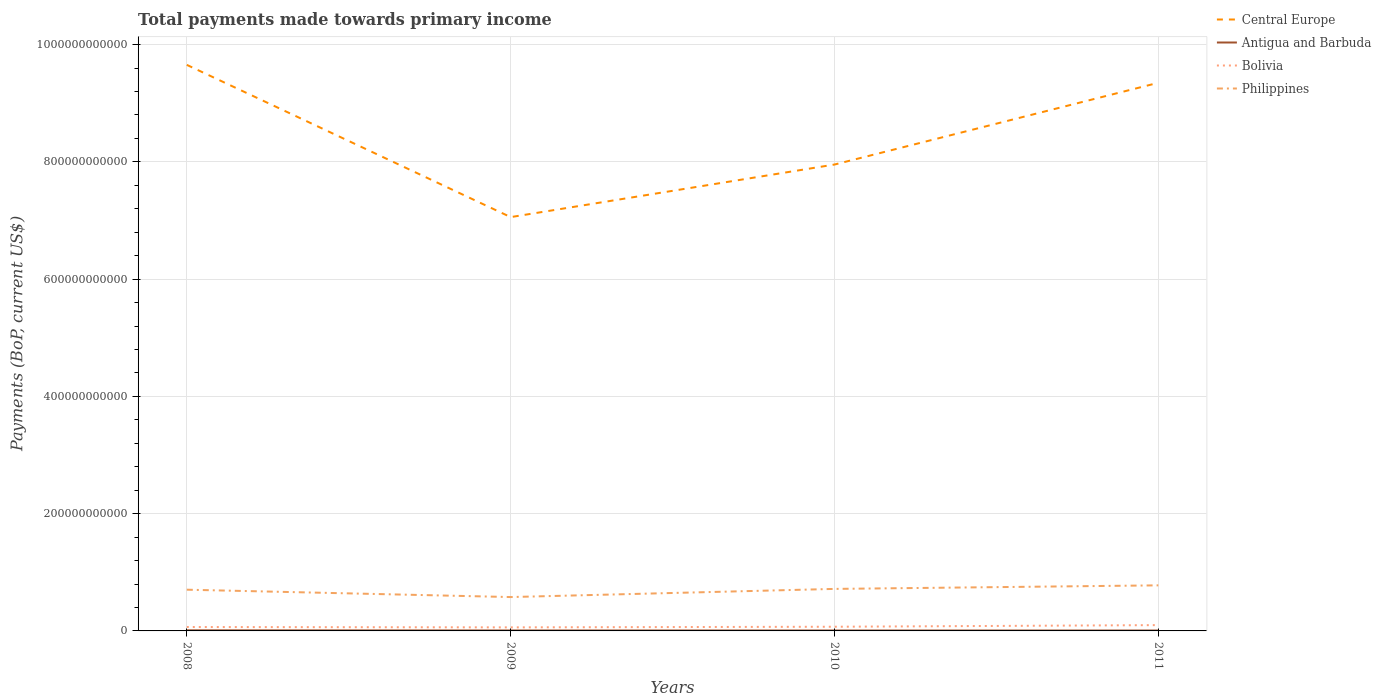Across all years, what is the maximum total payments made towards primary income in Bolivia?
Ensure brevity in your answer.  6.06e+09. In which year was the total payments made towards primary income in Bolivia maximum?
Offer a terse response. 2009. What is the total total payments made towards primary income in Antigua and Barbuda in the graph?
Your answer should be very brief. 3.02e+07. What is the difference between the highest and the second highest total payments made towards primary income in Philippines?
Keep it short and to the point. 2.00e+1. What is the difference between the highest and the lowest total payments made towards primary income in Philippines?
Your response must be concise. 3. How many lines are there?
Ensure brevity in your answer.  4. What is the difference between two consecutive major ticks on the Y-axis?
Ensure brevity in your answer.  2.00e+11. Does the graph contain any zero values?
Give a very brief answer. No. Does the graph contain grids?
Your answer should be compact. Yes. How many legend labels are there?
Your response must be concise. 4. What is the title of the graph?
Make the answer very short. Total payments made towards primary income. What is the label or title of the Y-axis?
Give a very brief answer. Payments (BoP, current US$). What is the Payments (BoP, current US$) in Central Europe in 2008?
Offer a very short reply. 9.65e+11. What is the Payments (BoP, current US$) in Antigua and Barbuda in 2008?
Give a very brief answer. 1.03e+09. What is the Payments (BoP, current US$) in Bolivia in 2008?
Give a very brief answer. 6.66e+09. What is the Payments (BoP, current US$) in Philippines in 2008?
Your response must be concise. 7.03e+1. What is the Payments (BoP, current US$) in Central Europe in 2009?
Ensure brevity in your answer.  7.06e+11. What is the Payments (BoP, current US$) of Antigua and Barbuda in 2009?
Ensure brevity in your answer.  7.70e+08. What is the Payments (BoP, current US$) of Bolivia in 2009?
Offer a terse response. 6.06e+09. What is the Payments (BoP, current US$) of Philippines in 2009?
Ensure brevity in your answer.  5.78e+1. What is the Payments (BoP, current US$) in Central Europe in 2010?
Your answer should be very brief. 7.95e+11. What is the Payments (BoP, current US$) of Antigua and Barbuda in 2010?
Make the answer very short. 7.22e+08. What is the Payments (BoP, current US$) in Bolivia in 2010?
Give a very brief answer. 7.13e+09. What is the Payments (BoP, current US$) in Philippines in 2010?
Offer a very short reply. 7.17e+1. What is the Payments (BoP, current US$) of Central Europe in 2011?
Offer a terse response. 9.35e+11. What is the Payments (BoP, current US$) in Antigua and Barbuda in 2011?
Your answer should be very brief. 6.91e+08. What is the Payments (BoP, current US$) in Bolivia in 2011?
Your response must be concise. 9.90e+09. What is the Payments (BoP, current US$) of Philippines in 2011?
Your answer should be compact. 7.77e+1. Across all years, what is the maximum Payments (BoP, current US$) in Central Europe?
Keep it short and to the point. 9.65e+11. Across all years, what is the maximum Payments (BoP, current US$) of Antigua and Barbuda?
Make the answer very short. 1.03e+09. Across all years, what is the maximum Payments (BoP, current US$) of Bolivia?
Provide a succinct answer. 9.90e+09. Across all years, what is the maximum Payments (BoP, current US$) in Philippines?
Make the answer very short. 7.77e+1. Across all years, what is the minimum Payments (BoP, current US$) of Central Europe?
Provide a succinct answer. 7.06e+11. Across all years, what is the minimum Payments (BoP, current US$) in Antigua and Barbuda?
Your answer should be very brief. 6.91e+08. Across all years, what is the minimum Payments (BoP, current US$) in Bolivia?
Provide a short and direct response. 6.06e+09. Across all years, what is the minimum Payments (BoP, current US$) in Philippines?
Offer a terse response. 5.78e+1. What is the total Payments (BoP, current US$) in Central Europe in the graph?
Your answer should be very brief. 3.40e+12. What is the total Payments (BoP, current US$) of Antigua and Barbuda in the graph?
Offer a terse response. 3.21e+09. What is the total Payments (BoP, current US$) of Bolivia in the graph?
Give a very brief answer. 2.97e+1. What is the total Payments (BoP, current US$) of Philippines in the graph?
Keep it short and to the point. 2.77e+11. What is the difference between the Payments (BoP, current US$) of Central Europe in 2008 and that in 2009?
Your response must be concise. 2.60e+11. What is the difference between the Payments (BoP, current US$) in Antigua and Barbuda in 2008 and that in 2009?
Your answer should be very brief. 2.59e+08. What is the difference between the Payments (BoP, current US$) in Bolivia in 2008 and that in 2009?
Make the answer very short. 5.99e+08. What is the difference between the Payments (BoP, current US$) of Philippines in 2008 and that in 2009?
Ensure brevity in your answer.  1.26e+1. What is the difference between the Payments (BoP, current US$) in Central Europe in 2008 and that in 2010?
Give a very brief answer. 1.70e+11. What is the difference between the Payments (BoP, current US$) of Antigua and Barbuda in 2008 and that in 2010?
Ensure brevity in your answer.  3.08e+08. What is the difference between the Payments (BoP, current US$) of Bolivia in 2008 and that in 2010?
Ensure brevity in your answer.  -4.65e+08. What is the difference between the Payments (BoP, current US$) of Philippines in 2008 and that in 2010?
Your answer should be compact. -1.35e+09. What is the difference between the Payments (BoP, current US$) in Central Europe in 2008 and that in 2011?
Provide a short and direct response. 3.06e+1. What is the difference between the Payments (BoP, current US$) of Antigua and Barbuda in 2008 and that in 2011?
Your answer should be compact. 3.38e+08. What is the difference between the Payments (BoP, current US$) of Bolivia in 2008 and that in 2011?
Your answer should be compact. -3.24e+09. What is the difference between the Payments (BoP, current US$) in Philippines in 2008 and that in 2011?
Keep it short and to the point. -7.40e+09. What is the difference between the Payments (BoP, current US$) of Central Europe in 2009 and that in 2010?
Provide a short and direct response. -8.97e+1. What is the difference between the Payments (BoP, current US$) of Antigua and Barbuda in 2009 and that in 2010?
Provide a succinct answer. 4.88e+07. What is the difference between the Payments (BoP, current US$) of Bolivia in 2009 and that in 2010?
Make the answer very short. -1.06e+09. What is the difference between the Payments (BoP, current US$) in Philippines in 2009 and that in 2010?
Offer a terse response. -1.39e+1. What is the difference between the Payments (BoP, current US$) in Central Europe in 2009 and that in 2011?
Offer a very short reply. -2.29e+11. What is the difference between the Payments (BoP, current US$) in Antigua and Barbuda in 2009 and that in 2011?
Your response must be concise. 7.91e+07. What is the difference between the Payments (BoP, current US$) of Bolivia in 2009 and that in 2011?
Make the answer very short. -3.84e+09. What is the difference between the Payments (BoP, current US$) of Philippines in 2009 and that in 2011?
Give a very brief answer. -2.00e+1. What is the difference between the Payments (BoP, current US$) of Central Europe in 2010 and that in 2011?
Your answer should be very brief. -1.39e+11. What is the difference between the Payments (BoP, current US$) of Antigua and Barbuda in 2010 and that in 2011?
Give a very brief answer. 3.02e+07. What is the difference between the Payments (BoP, current US$) of Bolivia in 2010 and that in 2011?
Provide a short and direct response. -2.77e+09. What is the difference between the Payments (BoP, current US$) in Philippines in 2010 and that in 2011?
Your answer should be very brief. -6.06e+09. What is the difference between the Payments (BoP, current US$) of Central Europe in 2008 and the Payments (BoP, current US$) of Antigua and Barbuda in 2009?
Make the answer very short. 9.65e+11. What is the difference between the Payments (BoP, current US$) in Central Europe in 2008 and the Payments (BoP, current US$) in Bolivia in 2009?
Offer a very short reply. 9.59e+11. What is the difference between the Payments (BoP, current US$) in Central Europe in 2008 and the Payments (BoP, current US$) in Philippines in 2009?
Keep it short and to the point. 9.08e+11. What is the difference between the Payments (BoP, current US$) in Antigua and Barbuda in 2008 and the Payments (BoP, current US$) in Bolivia in 2009?
Your response must be concise. -5.03e+09. What is the difference between the Payments (BoP, current US$) of Antigua and Barbuda in 2008 and the Payments (BoP, current US$) of Philippines in 2009?
Give a very brief answer. -5.67e+1. What is the difference between the Payments (BoP, current US$) of Bolivia in 2008 and the Payments (BoP, current US$) of Philippines in 2009?
Provide a short and direct response. -5.11e+1. What is the difference between the Payments (BoP, current US$) in Central Europe in 2008 and the Payments (BoP, current US$) in Antigua and Barbuda in 2010?
Offer a terse response. 9.65e+11. What is the difference between the Payments (BoP, current US$) of Central Europe in 2008 and the Payments (BoP, current US$) of Bolivia in 2010?
Provide a short and direct response. 9.58e+11. What is the difference between the Payments (BoP, current US$) in Central Europe in 2008 and the Payments (BoP, current US$) in Philippines in 2010?
Your answer should be very brief. 8.94e+11. What is the difference between the Payments (BoP, current US$) in Antigua and Barbuda in 2008 and the Payments (BoP, current US$) in Bolivia in 2010?
Make the answer very short. -6.10e+09. What is the difference between the Payments (BoP, current US$) in Antigua and Barbuda in 2008 and the Payments (BoP, current US$) in Philippines in 2010?
Provide a short and direct response. -7.06e+1. What is the difference between the Payments (BoP, current US$) of Bolivia in 2008 and the Payments (BoP, current US$) of Philippines in 2010?
Your response must be concise. -6.50e+1. What is the difference between the Payments (BoP, current US$) of Central Europe in 2008 and the Payments (BoP, current US$) of Antigua and Barbuda in 2011?
Give a very brief answer. 9.65e+11. What is the difference between the Payments (BoP, current US$) in Central Europe in 2008 and the Payments (BoP, current US$) in Bolivia in 2011?
Your response must be concise. 9.55e+11. What is the difference between the Payments (BoP, current US$) of Central Europe in 2008 and the Payments (BoP, current US$) of Philippines in 2011?
Your answer should be compact. 8.88e+11. What is the difference between the Payments (BoP, current US$) of Antigua and Barbuda in 2008 and the Payments (BoP, current US$) of Bolivia in 2011?
Your answer should be compact. -8.87e+09. What is the difference between the Payments (BoP, current US$) of Antigua and Barbuda in 2008 and the Payments (BoP, current US$) of Philippines in 2011?
Your response must be concise. -7.67e+1. What is the difference between the Payments (BoP, current US$) in Bolivia in 2008 and the Payments (BoP, current US$) in Philippines in 2011?
Your answer should be compact. -7.11e+1. What is the difference between the Payments (BoP, current US$) in Central Europe in 2009 and the Payments (BoP, current US$) in Antigua and Barbuda in 2010?
Offer a very short reply. 7.05e+11. What is the difference between the Payments (BoP, current US$) of Central Europe in 2009 and the Payments (BoP, current US$) of Bolivia in 2010?
Keep it short and to the point. 6.99e+11. What is the difference between the Payments (BoP, current US$) of Central Europe in 2009 and the Payments (BoP, current US$) of Philippines in 2010?
Provide a succinct answer. 6.34e+11. What is the difference between the Payments (BoP, current US$) of Antigua and Barbuda in 2009 and the Payments (BoP, current US$) of Bolivia in 2010?
Provide a succinct answer. -6.36e+09. What is the difference between the Payments (BoP, current US$) of Antigua and Barbuda in 2009 and the Payments (BoP, current US$) of Philippines in 2010?
Provide a succinct answer. -7.09e+1. What is the difference between the Payments (BoP, current US$) of Bolivia in 2009 and the Payments (BoP, current US$) of Philippines in 2010?
Provide a short and direct response. -6.56e+1. What is the difference between the Payments (BoP, current US$) of Central Europe in 2009 and the Payments (BoP, current US$) of Antigua and Barbuda in 2011?
Your answer should be compact. 7.05e+11. What is the difference between the Payments (BoP, current US$) of Central Europe in 2009 and the Payments (BoP, current US$) of Bolivia in 2011?
Ensure brevity in your answer.  6.96e+11. What is the difference between the Payments (BoP, current US$) of Central Europe in 2009 and the Payments (BoP, current US$) of Philippines in 2011?
Make the answer very short. 6.28e+11. What is the difference between the Payments (BoP, current US$) of Antigua and Barbuda in 2009 and the Payments (BoP, current US$) of Bolivia in 2011?
Keep it short and to the point. -9.13e+09. What is the difference between the Payments (BoP, current US$) of Antigua and Barbuda in 2009 and the Payments (BoP, current US$) of Philippines in 2011?
Your response must be concise. -7.69e+1. What is the difference between the Payments (BoP, current US$) in Bolivia in 2009 and the Payments (BoP, current US$) in Philippines in 2011?
Provide a succinct answer. -7.17e+1. What is the difference between the Payments (BoP, current US$) of Central Europe in 2010 and the Payments (BoP, current US$) of Antigua and Barbuda in 2011?
Give a very brief answer. 7.95e+11. What is the difference between the Payments (BoP, current US$) of Central Europe in 2010 and the Payments (BoP, current US$) of Bolivia in 2011?
Give a very brief answer. 7.85e+11. What is the difference between the Payments (BoP, current US$) of Central Europe in 2010 and the Payments (BoP, current US$) of Philippines in 2011?
Give a very brief answer. 7.18e+11. What is the difference between the Payments (BoP, current US$) of Antigua and Barbuda in 2010 and the Payments (BoP, current US$) of Bolivia in 2011?
Make the answer very short. -9.18e+09. What is the difference between the Payments (BoP, current US$) in Antigua and Barbuda in 2010 and the Payments (BoP, current US$) in Philippines in 2011?
Keep it short and to the point. -7.70e+1. What is the difference between the Payments (BoP, current US$) in Bolivia in 2010 and the Payments (BoP, current US$) in Philippines in 2011?
Ensure brevity in your answer.  -7.06e+1. What is the average Payments (BoP, current US$) in Central Europe per year?
Give a very brief answer. 8.50e+11. What is the average Payments (BoP, current US$) of Antigua and Barbuda per year?
Provide a succinct answer. 8.03e+08. What is the average Payments (BoP, current US$) in Bolivia per year?
Offer a very short reply. 7.44e+09. What is the average Payments (BoP, current US$) of Philippines per year?
Your answer should be very brief. 6.94e+1. In the year 2008, what is the difference between the Payments (BoP, current US$) in Central Europe and Payments (BoP, current US$) in Antigua and Barbuda?
Your answer should be very brief. 9.64e+11. In the year 2008, what is the difference between the Payments (BoP, current US$) in Central Europe and Payments (BoP, current US$) in Bolivia?
Provide a succinct answer. 9.59e+11. In the year 2008, what is the difference between the Payments (BoP, current US$) in Central Europe and Payments (BoP, current US$) in Philippines?
Provide a short and direct response. 8.95e+11. In the year 2008, what is the difference between the Payments (BoP, current US$) in Antigua and Barbuda and Payments (BoP, current US$) in Bolivia?
Ensure brevity in your answer.  -5.63e+09. In the year 2008, what is the difference between the Payments (BoP, current US$) of Antigua and Barbuda and Payments (BoP, current US$) of Philippines?
Provide a succinct answer. -6.93e+1. In the year 2008, what is the difference between the Payments (BoP, current US$) of Bolivia and Payments (BoP, current US$) of Philippines?
Offer a terse response. -6.37e+1. In the year 2009, what is the difference between the Payments (BoP, current US$) of Central Europe and Payments (BoP, current US$) of Antigua and Barbuda?
Make the answer very short. 7.05e+11. In the year 2009, what is the difference between the Payments (BoP, current US$) of Central Europe and Payments (BoP, current US$) of Bolivia?
Offer a very short reply. 7.00e+11. In the year 2009, what is the difference between the Payments (BoP, current US$) in Central Europe and Payments (BoP, current US$) in Philippines?
Provide a short and direct response. 6.48e+11. In the year 2009, what is the difference between the Payments (BoP, current US$) of Antigua and Barbuda and Payments (BoP, current US$) of Bolivia?
Provide a succinct answer. -5.29e+09. In the year 2009, what is the difference between the Payments (BoP, current US$) of Antigua and Barbuda and Payments (BoP, current US$) of Philippines?
Your answer should be compact. -5.70e+1. In the year 2009, what is the difference between the Payments (BoP, current US$) in Bolivia and Payments (BoP, current US$) in Philippines?
Make the answer very short. -5.17e+1. In the year 2010, what is the difference between the Payments (BoP, current US$) of Central Europe and Payments (BoP, current US$) of Antigua and Barbuda?
Your response must be concise. 7.95e+11. In the year 2010, what is the difference between the Payments (BoP, current US$) in Central Europe and Payments (BoP, current US$) in Bolivia?
Give a very brief answer. 7.88e+11. In the year 2010, what is the difference between the Payments (BoP, current US$) in Central Europe and Payments (BoP, current US$) in Philippines?
Your answer should be compact. 7.24e+11. In the year 2010, what is the difference between the Payments (BoP, current US$) in Antigua and Barbuda and Payments (BoP, current US$) in Bolivia?
Your answer should be compact. -6.40e+09. In the year 2010, what is the difference between the Payments (BoP, current US$) in Antigua and Barbuda and Payments (BoP, current US$) in Philippines?
Your response must be concise. -7.09e+1. In the year 2010, what is the difference between the Payments (BoP, current US$) of Bolivia and Payments (BoP, current US$) of Philippines?
Your answer should be very brief. -6.45e+1. In the year 2011, what is the difference between the Payments (BoP, current US$) in Central Europe and Payments (BoP, current US$) in Antigua and Barbuda?
Make the answer very short. 9.34e+11. In the year 2011, what is the difference between the Payments (BoP, current US$) of Central Europe and Payments (BoP, current US$) of Bolivia?
Provide a short and direct response. 9.25e+11. In the year 2011, what is the difference between the Payments (BoP, current US$) of Central Europe and Payments (BoP, current US$) of Philippines?
Provide a short and direct response. 8.57e+11. In the year 2011, what is the difference between the Payments (BoP, current US$) of Antigua and Barbuda and Payments (BoP, current US$) of Bolivia?
Keep it short and to the point. -9.21e+09. In the year 2011, what is the difference between the Payments (BoP, current US$) in Antigua and Barbuda and Payments (BoP, current US$) in Philippines?
Ensure brevity in your answer.  -7.70e+1. In the year 2011, what is the difference between the Payments (BoP, current US$) in Bolivia and Payments (BoP, current US$) in Philippines?
Make the answer very short. -6.78e+1. What is the ratio of the Payments (BoP, current US$) in Central Europe in 2008 to that in 2009?
Offer a terse response. 1.37. What is the ratio of the Payments (BoP, current US$) of Antigua and Barbuda in 2008 to that in 2009?
Your answer should be compact. 1.34. What is the ratio of the Payments (BoP, current US$) in Bolivia in 2008 to that in 2009?
Ensure brevity in your answer.  1.1. What is the ratio of the Payments (BoP, current US$) of Philippines in 2008 to that in 2009?
Give a very brief answer. 1.22. What is the ratio of the Payments (BoP, current US$) in Central Europe in 2008 to that in 2010?
Give a very brief answer. 1.21. What is the ratio of the Payments (BoP, current US$) of Antigua and Barbuda in 2008 to that in 2010?
Give a very brief answer. 1.43. What is the ratio of the Payments (BoP, current US$) of Bolivia in 2008 to that in 2010?
Keep it short and to the point. 0.93. What is the ratio of the Payments (BoP, current US$) of Philippines in 2008 to that in 2010?
Provide a succinct answer. 0.98. What is the ratio of the Payments (BoP, current US$) in Central Europe in 2008 to that in 2011?
Offer a terse response. 1.03. What is the ratio of the Payments (BoP, current US$) in Antigua and Barbuda in 2008 to that in 2011?
Ensure brevity in your answer.  1.49. What is the ratio of the Payments (BoP, current US$) in Bolivia in 2008 to that in 2011?
Your answer should be compact. 0.67. What is the ratio of the Payments (BoP, current US$) in Philippines in 2008 to that in 2011?
Keep it short and to the point. 0.9. What is the ratio of the Payments (BoP, current US$) of Central Europe in 2009 to that in 2010?
Ensure brevity in your answer.  0.89. What is the ratio of the Payments (BoP, current US$) of Antigua and Barbuda in 2009 to that in 2010?
Provide a succinct answer. 1.07. What is the ratio of the Payments (BoP, current US$) in Bolivia in 2009 to that in 2010?
Provide a short and direct response. 0.85. What is the ratio of the Payments (BoP, current US$) in Philippines in 2009 to that in 2010?
Provide a short and direct response. 0.81. What is the ratio of the Payments (BoP, current US$) in Central Europe in 2009 to that in 2011?
Keep it short and to the point. 0.75. What is the ratio of the Payments (BoP, current US$) of Antigua and Barbuda in 2009 to that in 2011?
Provide a short and direct response. 1.11. What is the ratio of the Payments (BoP, current US$) in Bolivia in 2009 to that in 2011?
Provide a short and direct response. 0.61. What is the ratio of the Payments (BoP, current US$) in Philippines in 2009 to that in 2011?
Provide a succinct answer. 0.74. What is the ratio of the Payments (BoP, current US$) of Central Europe in 2010 to that in 2011?
Make the answer very short. 0.85. What is the ratio of the Payments (BoP, current US$) of Antigua and Barbuda in 2010 to that in 2011?
Offer a terse response. 1.04. What is the ratio of the Payments (BoP, current US$) of Bolivia in 2010 to that in 2011?
Make the answer very short. 0.72. What is the ratio of the Payments (BoP, current US$) in Philippines in 2010 to that in 2011?
Keep it short and to the point. 0.92. What is the difference between the highest and the second highest Payments (BoP, current US$) of Central Europe?
Ensure brevity in your answer.  3.06e+1. What is the difference between the highest and the second highest Payments (BoP, current US$) in Antigua and Barbuda?
Offer a very short reply. 2.59e+08. What is the difference between the highest and the second highest Payments (BoP, current US$) of Bolivia?
Offer a terse response. 2.77e+09. What is the difference between the highest and the second highest Payments (BoP, current US$) of Philippines?
Give a very brief answer. 6.06e+09. What is the difference between the highest and the lowest Payments (BoP, current US$) in Central Europe?
Keep it short and to the point. 2.60e+11. What is the difference between the highest and the lowest Payments (BoP, current US$) of Antigua and Barbuda?
Give a very brief answer. 3.38e+08. What is the difference between the highest and the lowest Payments (BoP, current US$) of Bolivia?
Offer a very short reply. 3.84e+09. What is the difference between the highest and the lowest Payments (BoP, current US$) of Philippines?
Provide a short and direct response. 2.00e+1. 